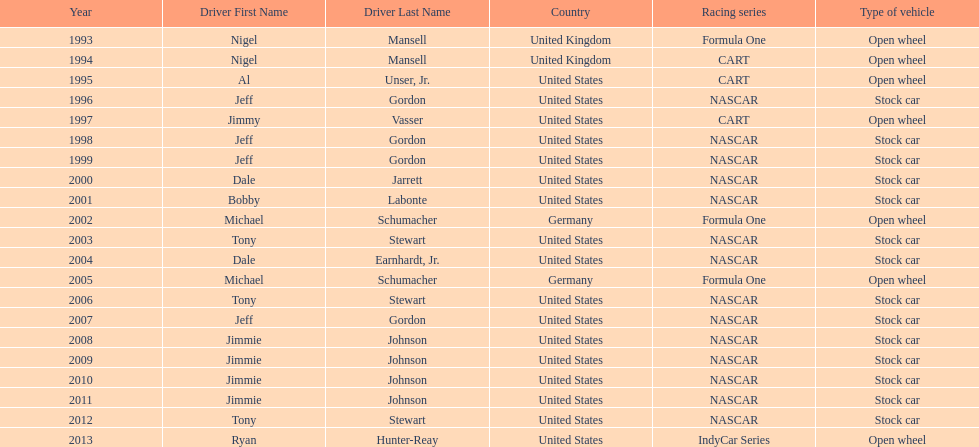Out of these drivers: nigel mansell, al unser, jr., michael schumacher, and jeff gordon, all but one has more than one espy award. who only has one espy award? Al Unser, Jr. 